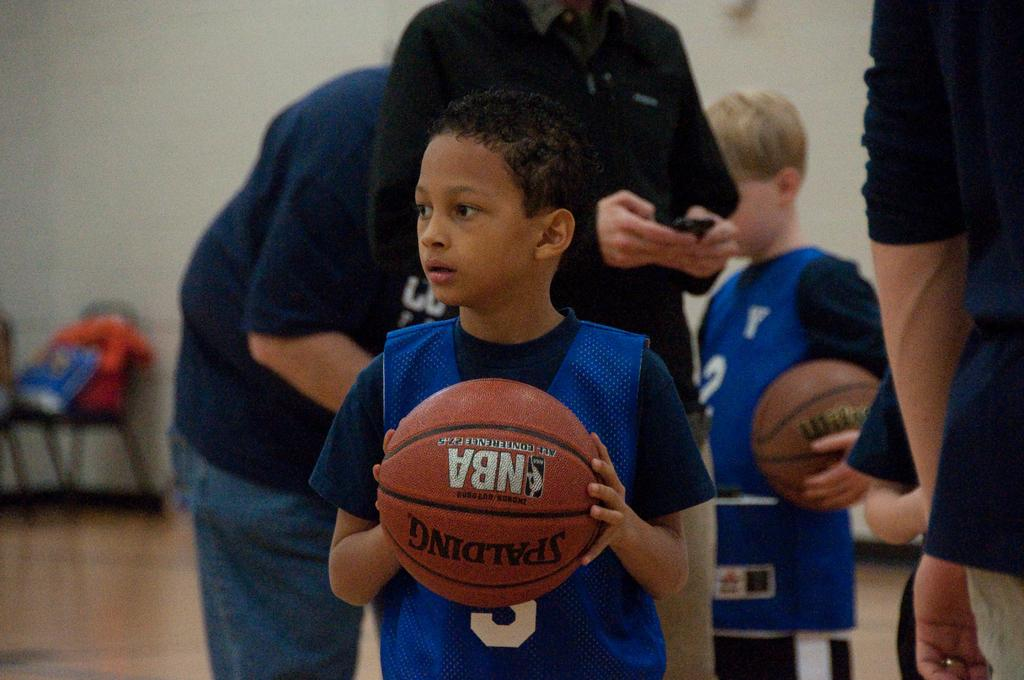What is one of the main features of the image? There is a wall in the image. What is located on the floor in the image? There is a chair on the floor in the image. What are the boys in the image holding? The boys in the image are holding balls in their hands. What is the position of the persons in the image? There are persons standing on the floor in the image. What type of organization is the boys' mother affiliated with in the image? There is no mention of a mother or any organization in the image. 